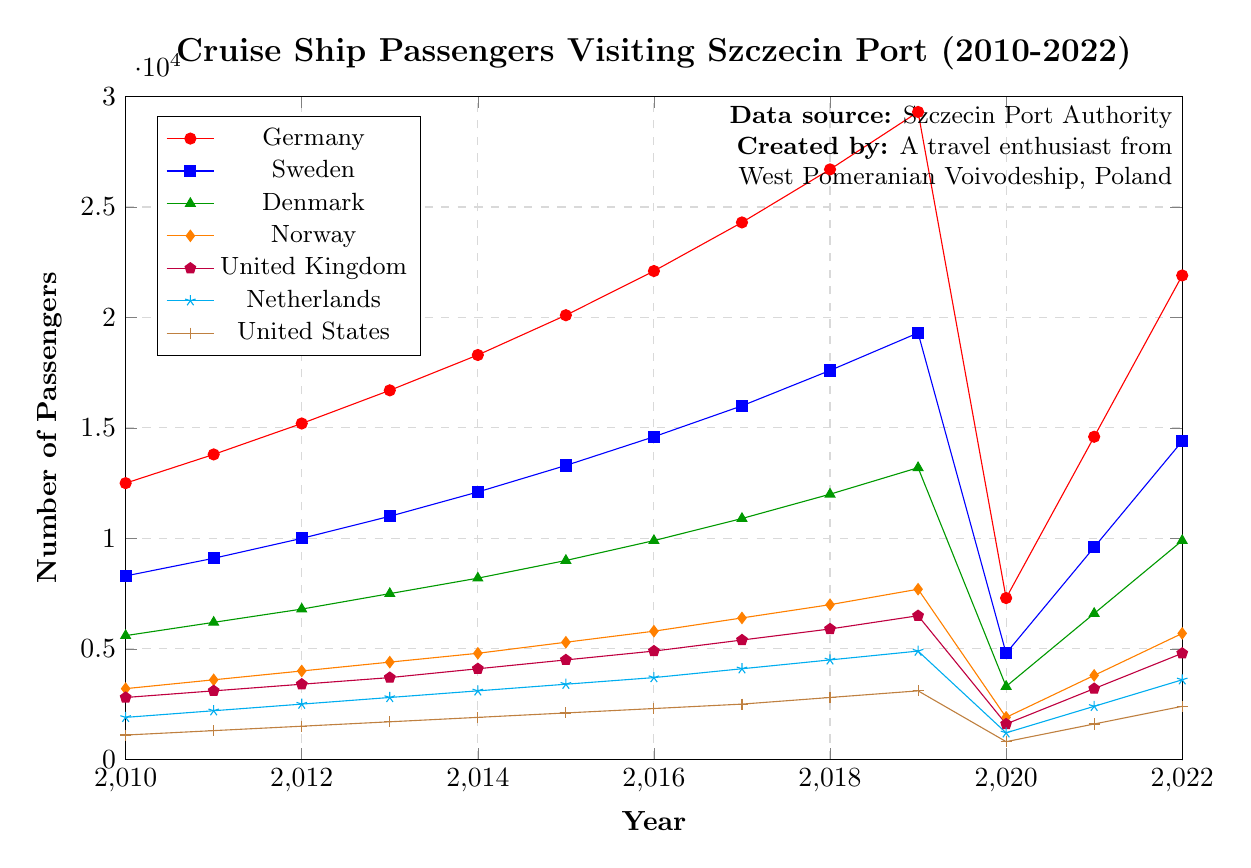What year saw the highest number of cruise ship passengers from Germany visiting Szczecin port? To find the highest number of cruise ship passengers from Germany, observe the red plot line and identify the year with the maximum value. In this case, the peak value for Germany is in 2019.
Answer: 2019 How many cruise ship passengers visited from Sweden and the United States combined in 2020? Look at the blue plot line for Sweden and the brown plot line for the United States in 2020. The passenger numbers are 4800 from Sweden and 800 from the United States. Summing these gives 4800 + 800 = 5600.
Answer: 5600 Which year had the lowest number of passengers from Norway, and how many were there? To find the lowest number, locate the orange plot line representing Norway and identify the minimum point. The lowest value for Norway is in 2020 with 1900 passengers.
Answer: 2020, 1900 Did Denmark ever have more than 9,000 cruise ship passengers in a year? Examine the green plot line for Denmark and see if it ever crosses the 9,000 mark. Yes, from 2015 onwards, the number of passengers exceeds 9,000 each year.
Answer: Yes Which country had the least number of cruise ship passengers in 2018? Compare the values for all countries in 2018 by looking at the plot lines. The brown plot line for the United States in 2018 indicates the lowest number, which is 2800.
Answer: United States What was the increase in the number of cruise ship passengers from the Netherlands from 2010 to 2019? Find the Netherlands' figures for 2010 and 2019. The numbers are 1900 in 2010 and 4900 in 2019. Calculate the difference: 4900 - 1900 = 3000.
Answer: 3000 How did the number of cruise ship passengers from the United Kingdom change between 2020 and 2021? Observe the purple plot line for the United Kingdom between 2020 and 2021. The numbers are 1600 in 2020 and 3200 in 2021. The change is 3200 - 1600 = 1600.
Answer: Increased by 1600 Which country had the most significant drop in cruise ship passengers in 2020 compared to 2019? Compare the decrease for each country between 2019 and 2020. The red plot line for Germany shows the biggest drop from 29300 to 7300, which is a decrease of 22000.
Answer: Germany On average, how many cruise ship passengers visited Szczecin port from Norway annually between 2010 and 2019? Calculate the average of the Norwegian passenger numbers from 2010 to 2019. Sum up the values (3200 + 3600 + 4000 + 4400 + 4800 + 5300 + 5800 + 6400 + 7000 + 7700 = 52200) and divide by 10 (52200/10).
Answer: 5220 